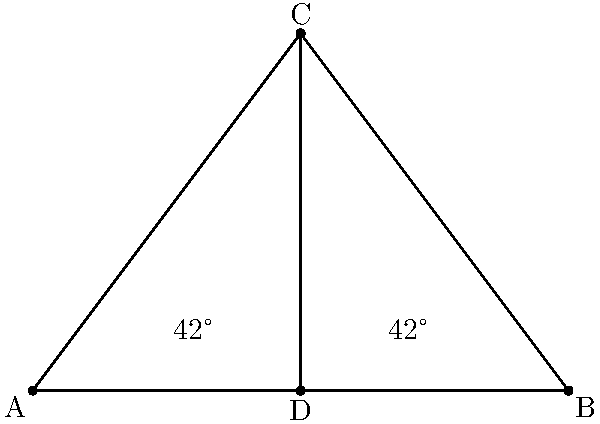On a map of NYC, three intersecting streets form two triangles as shown. If the angles at the base of the larger triangle are both 42°, prove that the two triangles are congruent and determine the measure of angle ACD. Let's approach this step-by-step:

1) In the larger triangle ABC:
   - We're given that $\angle CAB = \angle CBA = 42°$
   - Since the sum of angles in a triangle is 180°, we can find $\angle ACB$:
     $\angle ACB = 180° - (42° + 42°) = 96°$

2) The line CD bisects $\angle ACB$, creating two smaller triangles: ACD and BCD.

3) Since CD bisects $\angle ACB$, we know that:
   $\angle ACD = \angle BCD = 96° \div 2 = 48°$

4) Now, let's look at triangle ACD:
   - We know $\angle CAD = 42°$ (given)
   - We just calculated $\angle ACD = 48°$
   - We can find $\angle ADC$:
     $\angle ADC = 180° - (42° + 48°) = 90°$

5) Similarly, for triangle BCD:
   - $\angle CBD = 42°$ (given)
   - $\angle BCD = 48°$ (calculated in step 3)
   - $\angle BDC = 180° - (42° + 48°) = 90°$

6) Now we can see that triangles ACD and BCD are congruent because:
   - They share the side CD
   - $\angle ACD = \angle BCD = 48°$
   - $\angle ADC = \angle BDC = 90°$

This satisfies the AAS (Angle-Angle-Side) congruence criterion.

Therefore, the two triangles are congruent, and the measure of angle ACD is 48°.
Answer: 48° 